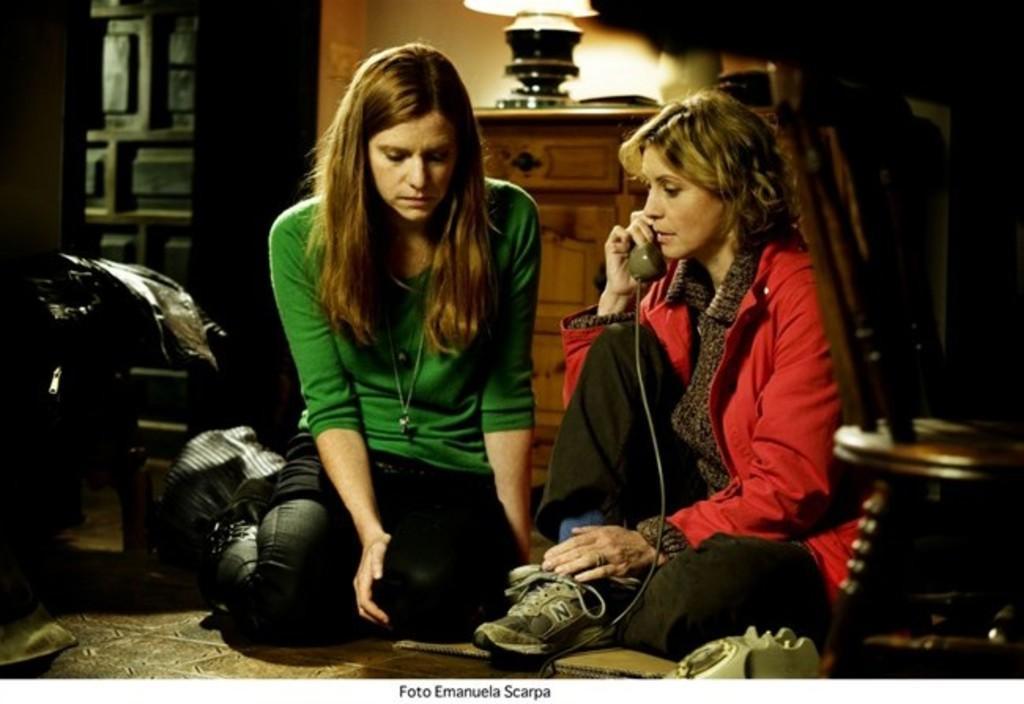In one or two sentences, can you explain what this image depicts? In this picture, we see a woman in the red jacket is sitting and she is holding a telephone receiver in her hand. I think she is talking on the telephone. Beside her, we see a woman in the green T-shirt is sitting on the floor. On the right side, we see a chair. Behind them, we see a cupboard or a table on which a lamp and some other objects are placed. On the left side, we see a chair on which a black bag is placed. In the background, we see a wall and a cupboard. 